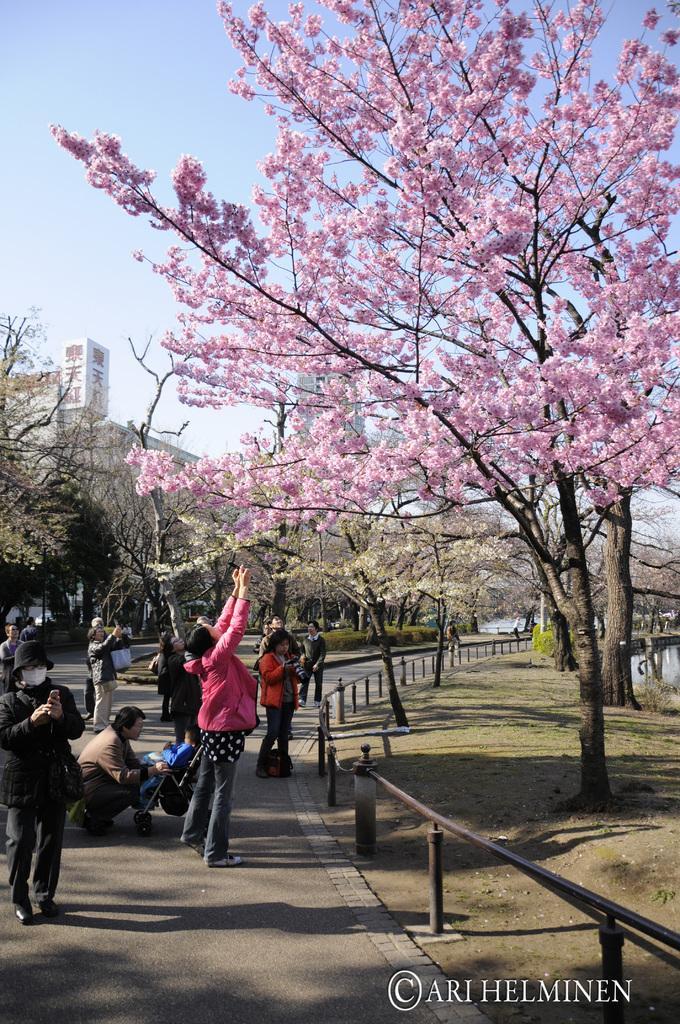Can you describe this image briefly? In the image we can see there are people standing on the road and there is a person sitting on the road. There is a baby buggy and there is a kid sitting in the buggy. There are flowers on the tree and there is small iron poles fencing. Behind there are trees and building. There is a clear sky. 